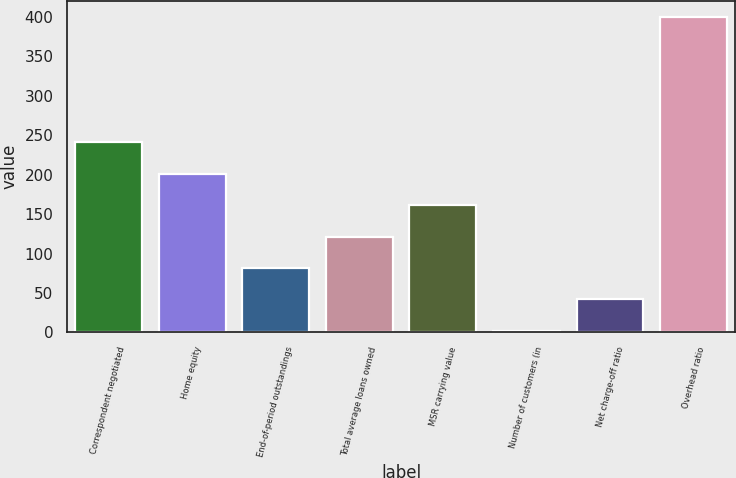Convert chart. <chart><loc_0><loc_0><loc_500><loc_500><bar_chart><fcel>Correspondent negotiated<fcel>Home equity<fcel>End-of-period outstandings<fcel>Total average loans owned<fcel>MSR carrying value<fcel>Number of customers (in<fcel>Net charge-off ratio<fcel>Overhead ratio<nl><fcel>240.8<fcel>201<fcel>81.6<fcel>121.4<fcel>161.2<fcel>2<fcel>41.8<fcel>400<nl></chart> 